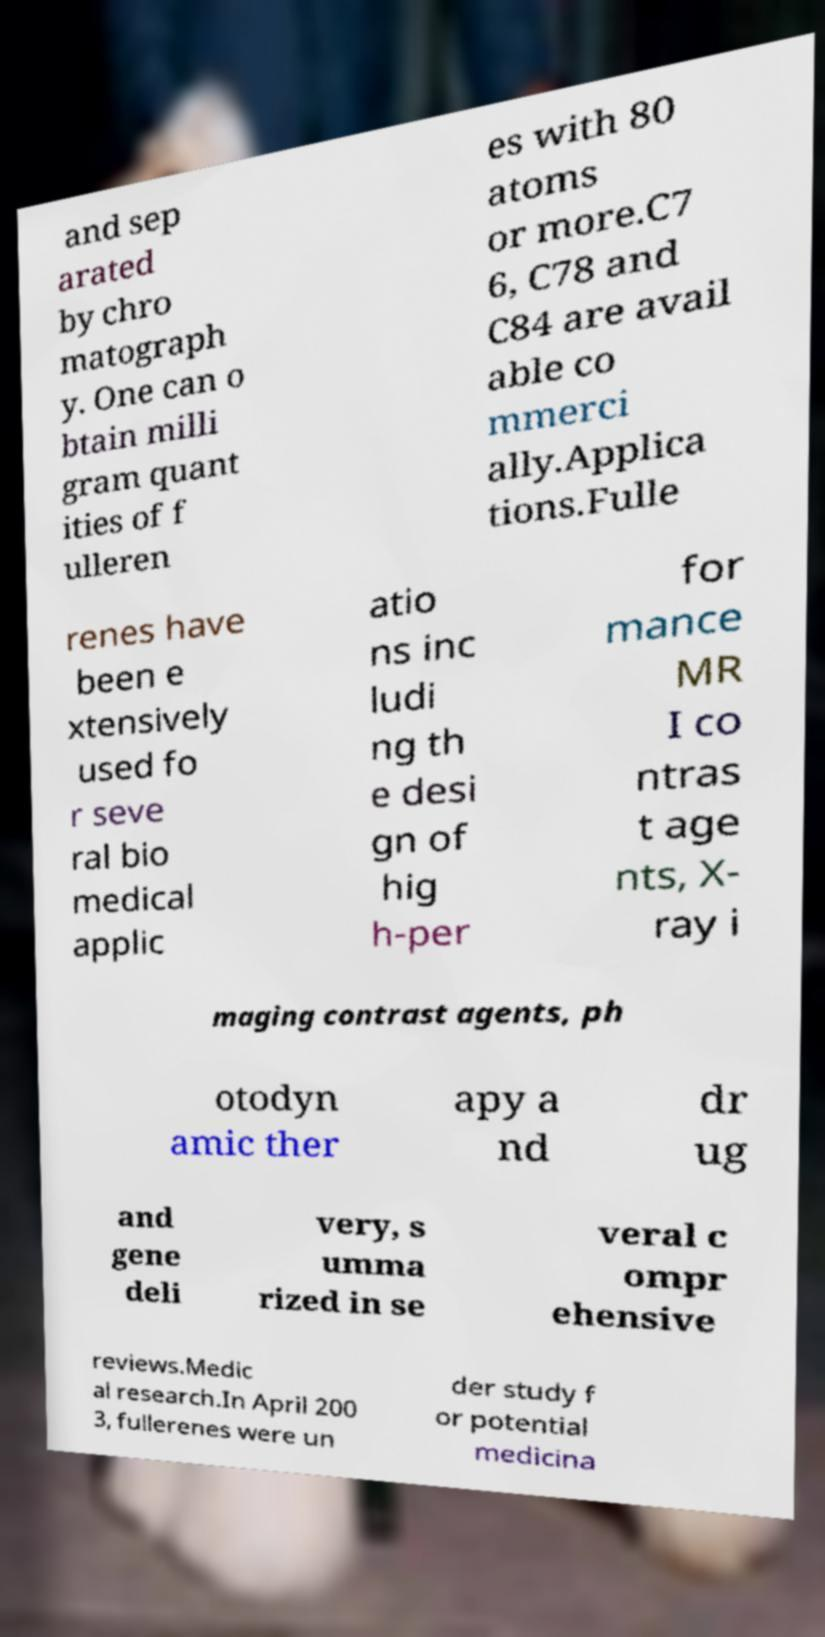Could you assist in decoding the text presented in this image and type it out clearly? and sep arated by chro matograph y. One can o btain milli gram quant ities of f ulleren es with 80 atoms or more.C7 6, C78 and C84 are avail able co mmerci ally.Applica tions.Fulle renes have been e xtensively used fo r seve ral bio medical applic atio ns inc ludi ng th e desi gn of hig h-per for mance MR I co ntras t age nts, X- ray i maging contrast agents, ph otodyn amic ther apy a nd dr ug and gene deli very, s umma rized in se veral c ompr ehensive reviews.Medic al research.In April 200 3, fullerenes were un der study f or potential medicina 